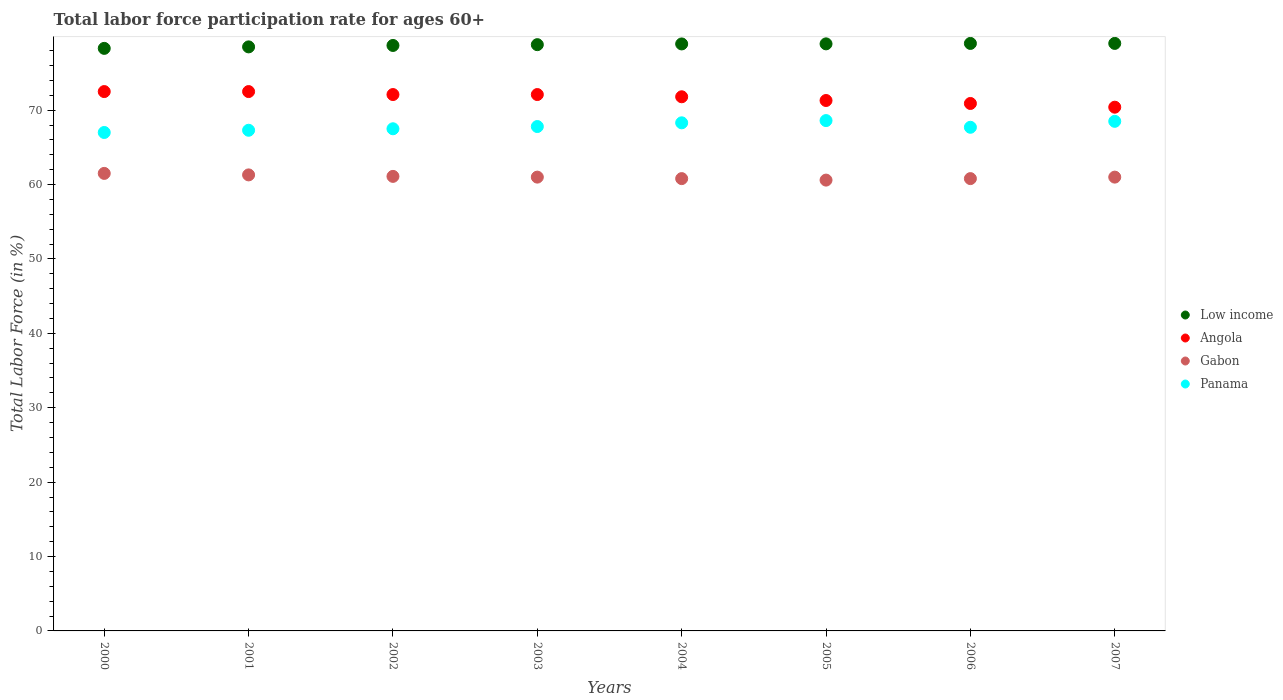What is the labor force participation rate in Angola in 2004?
Keep it short and to the point. 71.8. Across all years, what is the maximum labor force participation rate in Panama?
Offer a very short reply. 68.6. Across all years, what is the minimum labor force participation rate in Low income?
Your answer should be compact. 78.31. What is the total labor force participation rate in Angola in the graph?
Provide a short and direct response. 573.6. What is the difference between the labor force participation rate in Panama in 2001 and that in 2007?
Keep it short and to the point. -1.2. What is the difference between the labor force participation rate in Gabon in 2006 and the labor force participation rate in Low income in 2001?
Offer a terse response. -17.71. What is the average labor force participation rate in Angola per year?
Your answer should be very brief. 71.7. In the year 2002, what is the difference between the labor force participation rate in Angola and labor force participation rate in Panama?
Your answer should be compact. 4.6. In how many years, is the labor force participation rate in Angola greater than 40 %?
Make the answer very short. 8. What is the ratio of the labor force participation rate in Gabon in 2000 to that in 2001?
Your response must be concise. 1. Is the labor force participation rate in Gabon in 2000 less than that in 2002?
Offer a terse response. No. What is the difference between the highest and the second highest labor force participation rate in Panama?
Your answer should be compact. 0.1. What is the difference between the highest and the lowest labor force participation rate in Gabon?
Your answer should be very brief. 0.9. In how many years, is the labor force participation rate in Panama greater than the average labor force participation rate in Panama taken over all years?
Your response must be concise. 3. Is the labor force participation rate in Panama strictly greater than the labor force participation rate in Low income over the years?
Provide a succinct answer. No. Is the labor force participation rate in Angola strictly less than the labor force participation rate in Panama over the years?
Your answer should be compact. No. How many dotlines are there?
Your answer should be compact. 4. How many years are there in the graph?
Your answer should be very brief. 8. What is the difference between two consecutive major ticks on the Y-axis?
Give a very brief answer. 10. Does the graph contain any zero values?
Keep it short and to the point. No. Does the graph contain grids?
Provide a short and direct response. No. How many legend labels are there?
Make the answer very short. 4. How are the legend labels stacked?
Your answer should be very brief. Vertical. What is the title of the graph?
Provide a succinct answer. Total labor force participation rate for ages 60+. What is the label or title of the X-axis?
Keep it short and to the point. Years. What is the label or title of the Y-axis?
Your answer should be very brief. Total Labor Force (in %). What is the Total Labor Force (in %) of Low income in 2000?
Your answer should be compact. 78.31. What is the Total Labor Force (in %) of Angola in 2000?
Make the answer very short. 72.5. What is the Total Labor Force (in %) in Gabon in 2000?
Provide a short and direct response. 61.5. What is the Total Labor Force (in %) in Panama in 2000?
Offer a very short reply. 67. What is the Total Labor Force (in %) of Low income in 2001?
Your response must be concise. 78.51. What is the Total Labor Force (in %) in Angola in 2001?
Provide a succinct answer. 72.5. What is the Total Labor Force (in %) in Gabon in 2001?
Give a very brief answer. 61.3. What is the Total Labor Force (in %) in Panama in 2001?
Provide a short and direct response. 67.3. What is the Total Labor Force (in %) in Low income in 2002?
Provide a succinct answer. 78.7. What is the Total Labor Force (in %) of Angola in 2002?
Your response must be concise. 72.1. What is the Total Labor Force (in %) in Gabon in 2002?
Keep it short and to the point. 61.1. What is the Total Labor Force (in %) of Panama in 2002?
Your answer should be very brief. 67.5. What is the Total Labor Force (in %) of Low income in 2003?
Provide a short and direct response. 78.81. What is the Total Labor Force (in %) in Angola in 2003?
Make the answer very short. 72.1. What is the Total Labor Force (in %) of Panama in 2003?
Give a very brief answer. 67.8. What is the Total Labor Force (in %) of Low income in 2004?
Your answer should be compact. 78.9. What is the Total Labor Force (in %) of Angola in 2004?
Ensure brevity in your answer.  71.8. What is the Total Labor Force (in %) of Gabon in 2004?
Provide a succinct answer. 60.8. What is the Total Labor Force (in %) in Panama in 2004?
Keep it short and to the point. 68.3. What is the Total Labor Force (in %) in Low income in 2005?
Your response must be concise. 78.91. What is the Total Labor Force (in %) of Angola in 2005?
Your response must be concise. 71.3. What is the Total Labor Force (in %) of Gabon in 2005?
Your response must be concise. 60.6. What is the Total Labor Force (in %) in Panama in 2005?
Your answer should be very brief. 68.6. What is the Total Labor Force (in %) in Low income in 2006?
Make the answer very short. 78.97. What is the Total Labor Force (in %) of Angola in 2006?
Ensure brevity in your answer.  70.9. What is the Total Labor Force (in %) in Gabon in 2006?
Your response must be concise. 60.8. What is the Total Labor Force (in %) in Panama in 2006?
Your response must be concise. 67.7. What is the Total Labor Force (in %) in Low income in 2007?
Make the answer very short. 78.97. What is the Total Labor Force (in %) of Angola in 2007?
Keep it short and to the point. 70.4. What is the Total Labor Force (in %) of Panama in 2007?
Make the answer very short. 68.5. Across all years, what is the maximum Total Labor Force (in %) in Low income?
Your answer should be very brief. 78.97. Across all years, what is the maximum Total Labor Force (in %) of Angola?
Give a very brief answer. 72.5. Across all years, what is the maximum Total Labor Force (in %) in Gabon?
Offer a terse response. 61.5. Across all years, what is the maximum Total Labor Force (in %) of Panama?
Offer a very short reply. 68.6. Across all years, what is the minimum Total Labor Force (in %) in Low income?
Provide a short and direct response. 78.31. Across all years, what is the minimum Total Labor Force (in %) of Angola?
Your answer should be very brief. 70.4. Across all years, what is the minimum Total Labor Force (in %) of Gabon?
Ensure brevity in your answer.  60.6. Across all years, what is the minimum Total Labor Force (in %) of Panama?
Your answer should be very brief. 67. What is the total Total Labor Force (in %) of Low income in the graph?
Ensure brevity in your answer.  630.08. What is the total Total Labor Force (in %) in Angola in the graph?
Your response must be concise. 573.6. What is the total Total Labor Force (in %) in Gabon in the graph?
Offer a very short reply. 488.1. What is the total Total Labor Force (in %) in Panama in the graph?
Ensure brevity in your answer.  542.7. What is the difference between the Total Labor Force (in %) in Low income in 2000 and that in 2001?
Your response must be concise. -0.2. What is the difference between the Total Labor Force (in %) in Angola in 2000 and that in 2001?
Give a very brief answer. 0. What is the difference between the Total Labor Force (in %) of Low income in 2000 and that in 2002?
Give a very brief answer. -0.39. What is the difference between the Total Labor Force (in %) of Angola in 2000 and that in 2002?
Keep it short and to the point. 0.4. What is the difference between the Total Labor Force (in %) in Gabon in 2000 and that in 2002?
Ensure brevity in your answer.  0.4. What is the difference between the Total Labor Force (in %) of Panama in 2000 and that in 2002?
Offer a terse response. -0.5. What is the difference between the Total Labor Force (in %) in Low income in 2000 and that in 2003?
Offer a terse response. -0.5. What is the difference between the Total Labor Force (in %) in Panama in 2000 and that in 2003?
Your response must be concise. -0.8. What is the difference between the Total Labor Force (in %) of Low income in 2000 and that in 2004?
Give a very brief answer. -0.6. What is the difference between the Total Labor Force (in %) of Gabon in 2000 and that in 2004?
Keep it short and to the point. 0.7. What is the difference between the Total Labor Force (in %) of Low income in 2000 and that in 2005?
Keep it short and to the point. -0.61. What is the difference between the Total Labor Force (in %) of Gabon in 2000 and that in 2005?
Offer a terse response. 0.9. What is the difference between the Total Labor Force (in %) of Low income in 2000 and that in 2006?
Give a very brief answer. -0.66. What is the difference between the Total Labor Force (in %) in Gabon in 2000 and that in 2006?
Your response must be concise. 0.7. What is the difference between the Total Labor Force (in %) of Panama in 2000 and that in 2006?
Provide a succinct answer. -0.7. What is the difference between the Total Labor Force (in %) in Low income in 2000 and that in 2007?
Ensure brevity in your answer.  -0.67. What is the difference between the Total Labor Force (in %) of Angola in 2000 and that in 2007?
Offer a terse response. 2.1. What is the difference between the Total Labor Force (in %) of Gabon in 2000 and that in 2007?
Your response must be concise. 0.5. What is the difference between the Total Labor Force (in %) of Low income in 2001 and that in 2002?
Offer a terse response. -0.19. What is the difference between the Total Labor Force (in %) in Gabon in 2001 and that in 2002?
Ensure brevity in your answer.  0.2. What is the difference between the Total Labor Force (in %) of Panama in 2001 and that in 2002?
Give a very brief answer. -0.2. What is the difference between the Total Labor Force (in %) of Low income in 2001 and that in 2003?
Your answer should be very brief. -0.3. What is the difference between the Total Labor Force (in %) in Angola in 2001 and that in 2003?
Offer a very short reply. 0.4. What is the difference between the Total Labor Force (in %) of Low income in 2001 and that in 2004?
Provide a short and direct response. -0.4. What is the difference between the Total Labor Force (in %) in Angola in 2001 and that in 2004?
Ensure brevity in your answer.  0.7. What is the difference between the Total Labor Force (in %) of Low income in 2001 and that in 2005?
Make the answer very short. -0.41. What is the difference between the Total Labor Force (in %) of Angola in 2001 and that in 2005?
Your response must be concise. 1.2. What is the difference between the Total Labor Force (in %) in Gabon in 2001 and that in 2005?
Make the answer very short. 0.7. What is the difference between the Total Labor Force (in %) in Panama in 2001 and that in 2005?
Offer a very short reply. -1.3. What is the difference between the Total Labor Force (in %) of Low income in 2001 and that in 2006?
Provide a succinct answer. -0.46. What is the difference between the Total Labor Force (in %) in Angola in 2001 and that in 2006?
Ensure brevity in your answer.  1.6. What is the difference between the Total Labor Force (in %) of Gabon in 2001 and that in 2006?
Offer a very short reply. 0.5. What is the difference between the Total Labor Force (in %) in Panama in 2001 and that in 2006?
Ensure brevity in your answer.  -0.4. What is the difference between the Total Labor Force (in %) of Low income in 2001 and that in 2007?
Ensure brevity in your answer.  -0.47. What is the difference between the Total Labor Force (in %) in Gabon in 2001 and that in 2007?
Your response must be concise. 0.3. What is the difference between the Total Labor Force (in %) of Low income in 2002 and that in 2003?
Ensure brevity in your answer.  -0.11. What is the difference between the Total Labor Force (in %) of Gabon in 2002 and that in 2003?
Make the answer very short. 0.1. What is the difference between the Total Labor Force (in %) of Panama in 2002 and that in 2003?
Keep it short and to the point. -0.3. What is the difference between the Total Labor Force (in %) of Low income in 2002 and that in 2004?
Keep it short and to the point. -0.2. What is the difference between the Total Labor Force (in %) of Low income in 2002 and that in 2005?
Make the answer very short. -0.21. What is the difference between the Total Labor Force (in %) in Low income in 2002 and that in 2006?
Your response must be concise. -0.27. What is the difference between the Total Labor Force (in %) of Angola in 2002 and that in 2006?
Ensure brevity in your answer.  1.2. What is the difference between the Total Labor Force (in %) in Low income in 2002 and that in 2007?
Your answer should be compact. -0.28. What is the difference between the Total Labor Force (in %) in Gabon in 2002 and that in 2007?
Your answer should be very brief. 0.1. What is the difference between the Total Labor Force (in %) of Panama in 2002 and that in 2007?
Your response must be concise. -1. What is the difference between the Total Labor Force (in %) in Low income in 2003 and that in 2004?
Your response must be concise. -0.1. What is the difference between the Total Labor Force (in %) of Gabon in 2003 and that in 2004?
Keep it short and to the point. 0.2. What is the difference between the Total Labor Force (in %) of Panama in 2003 and that in 2004?
Ensure brevity in your answer.  -0.5. What is the difference between the Total Labor Force (in %) of Low income in 2003 and that in 2005?
Your answer should be compact. -0.11. What is the difference between the Total Labor Force (in %) of Gabon in 2003 and that in 2005?
Provide a short and direct response. 0.4. What is the difference between the Total Labor Force (in %) in Low income in 2003 and that in 2006?
Your answer should be compact. -0.17. What is the difference between the Total Labor Force (in %) of Gabon in 2003 and that in 2006?
Make the answer very short. 0.2. What is the difference between the Total Labor Force (in %) in Low income in 2003 and that in 2007?
Provide a succinct answer. -0.17. What is the difference between the Total Labor Force (in %) in Angola in 2003 and that in 2007?
Your response must be concise. 1.7. What is the difference between the Total Labor Force (in %) of Low income in 2004 and that in 2005?
Keep it short and to the point. -0.01. What is the difference between the Total Labor Force (in %) in Angola in 2004 and that in 2005?
Keep it short and to the point. 0.5. What is the difference between the Total Labor Force (in %) in Low income in 2004 and that in 2006?
Offer a very short reply. -0.07. What is the difference between the Total Labor Force (in %) in Panama in 2004 and that in 2006?
Ensure brevity in your answer.  0.6. What is the difference between the Total Labor Force (in %) in Low income in 2004 and that in 2007?
Your answer should be very brief. -0.07. What is the difference between the Total Labor Force (in %) in Gabon in 2004 and that in 2007?
Keep it short and to the point. -0.2. What is the difference between the Total Labor Force (in %) in Panama in 2004 and that in 2007?
Your answer should be very brief. -0.2. What is the difference between the Total Labor Force (in %) in Low income in 2005 and that in 2006?
Your response must be concise. -0.06. What is the difference between the Total Labor Force (in %) of Angola in 2005 and that in 2006?
Your answer should be compact. 0.4. What is the difference between the Total Labor Force (in %) of Gabon in 2005 and that in 2006?
Offer a terse response. -0.2. What is the difference between the Total Labor Force (in %) in Low income in 2005 and that in 2007?
Make the answer very short. -0.06. What is the difference between the Total Labor Force (in %) of Angola in 2005 and that in 2007?
Offer a terse response. 0.9. What is the difference between the Total Labor Force (in %) of Low income in 2006 and that in 2007?
Ensure brevity in your answer.  -0. What is the difference between the Total Labor Force (in %) in Low income in 2000 and the Total Labor Force (in %) in Angola in 2001?
Provide a succinct answer. 5.81. What is the difference between the Total Labor Force (in %) of Low income in 2000 and the Total Labor Force (in %) of Gabon in 2001?
Ensure brevity in your answer.  17.01. What is the difference between the Total Labor Force (in %) in Low income in 2000 and the Total Labor Force (in %) in Panama in 2001?
Give a very brief answer. 11.01. What is the difference between the Total Labor Force (in %) in Gabon in 2000 and the Total Labor Force (in %) in Panama in 2001?
Ensure brevity in your answer.  -5.8. What is the difference between the Total Labor Force (in %) of Low income in 2000 and the Total Labor Force (in %) of Angola in 2002?
Your answer should be very brief. 6.21. What is the difference between the Total Labor Force (in %) in Low income in 2000 and the Total Labor Force (in %) in Gabon in 2002?
Ensure brevity in your answer.  17.21. What is the difference between the Total Labor Force (in %) in Low income in 2000 and the Total Labor Force (in %) in Panama in 2002?
Ensure brevity in your answer.  10.81. What is the difference between the Total Labor Force (in %) in Angola in 2000 and the Total Labor Force (in %) in Panama in 2002?
Keep it short and to the point. 5. What is the difference between the Total Labor Force (in %) of Gabon in 2000 and the Total Labor Force (in %) of Panama in 2002?
Your answer should be compact. -6. What is the difference between the Total Labor Force (in %) of Low income in 2000 and the Total Labor Force (in %) of Angola in 2003?
Your answer should be compact. 6.21. What is the difference between the Total Labor Force (in %) in Low income in 2000 and the Total Labor Force (in %) in Gabon in 2003?
Your answer should be very brief. 17.31. What is the difference between the Total Labor Force (in %) of Low income in 2000 and the Total Labor Force (in %) of Panama in 2003?
Your answer should be very brief. 10.51. What is the difference between the Total Labor Force (in %) in Angola in 2000 and the Total Labor Force (in %) in Panama in 2003?
Provide a succinct answer. 4.7. What is the difference between the Total Labor Force (in %) of Low income in 2000 and the Total Labor Force (in %) of Angola in 2004?
Your response must be concise. 6.51. What is the difference between the Total Labor Force (in %) in Low income in 2000 and the Total Labor Force (in %) in Gabon in 2004?
Offer a terse response. 17.51. What is the difference between the Total Labor Force (in %) in Low income in 2000 and the Total Labor Force (in %) in Panama in 2004?
Offer a very short reply. 10.01. What is the difference between the Total Labor Force (in %) of Angola in 2000 and the Total Labor Force (in %) of Gabon in 2004?
Your answer should be very brief. 11.7. What is the difference between the Total Labor Force (in %) of Angola in 2000 and the Total Labor Force (in %) of Panama in 2004?
Your response must be concise. 4.2. What is the difference between the Total Labor Force (in %) in Low income in 2000 and the Total Labor Force (in %) in Angola in 2005?
Give a very brief answer. 7.01. What is the difference between the Total Labor Force (in %) in Low income in 2000 and the Total Labor Force (in %) in Gabon in 2005?
Make the answer very short. 17.71. What is the difference between the Total Labor Force (in %) in Low income in 2000 and the Total Labor Force (in %) in Panama in 2005?
Your answer should be very brief. 9.71. What is the difference between the Total Labor Force (in %) of Angola in 2000 and the Total Labor Force (in %) of Gabon in 2005?
Keep it short and to the point. 11.9. What is the difference between the Total Labor Force (in %) in Angola in 2000 and the Total Labor Force (in %) in Panama in 2005?
Your answer should be very brief. 3.9. What is the difference between the Total Labor Force (in %) in Gabon in 2000 and the Total Labor Force (in %) in Panama in 2005?
Your answer should be very brief. -7.1. What is the difference between the Total Labor Force (in %) of Low income in 2000 and the Total Labor Force (in %) of Angola in 2006?
Keep it short and to the point. 7.41. What is the difference between the Total Labor Force (in %) of Low income in 2000 and the Total Labor Force (in %) of Gabon in 2006?
Your answer should be very brief. 17.51. What is the difference between the Total Labor Force (in %) in Low income in 2000 and the Total Labor Force (in %) in Panama in 2006?
Your answer should be very brief. 10.61. What is the difference between the Total Labor Force (in %) of Low income in 2000 and the Total Labor Force (in %) of Angola in 2007?
Provide a succinct answer. 7.91. What is the difference between the Total Labor Force (in %) in Low income in 2000 and the Total Labor Force (in %) in Gabon in 2007?
Make the answer very short. 17.31. What is the difference between the Total Labor Force (in %) of Low income in 2000 and the Total Labor Force (in %) of Panama in 2007?
Ensure brevity in your answer.  9.81. What is the difference between the Total Labor Force (in %) in Angola in 2000 and the Total Labor Force (in %) in Gabon in 2007?
Offer a terse response. 11.5. What is the difference between the Total Labor Force (in %) of Angola in 2000 and the Total Labor Force (in %) of Panama in 2007?
Offer a very short reply. 4. What is the difference between the Total Labor Force (in %) of Gabon in 2000 and the Total Labor Force (in %) of Panama in 2007?
Keep it short and to the point. -7. What is the difference between the Total Labor Force (in %) in Low income in 2001 and the Total Labor Force (in %) in Angola in 2002?
Provide a short and direct response. 6.41. What is the difference between the Total Labor Force (in %) in Low income in 2001 and the Total Labor Force (in %) in Gabon in 2002?
Provide a succinct answer. 17.41. What is the difference between the Total Labor Force (in %) in Low income in 2001 and the Total Labor Force (in %) in Panama in 2002?
Offer a very short reply. 11.01. What is the difference between the Total Labor Force (in %) of Angola in 2001 and the Total Labor Force (in %) of Panama in 2002?
Your answer should be compact. 5. What is the difference between the Total Labor Force (in %) of Low income in 2001 and the Total Labor Force (in %) of Angola in 2003?
Your answer should be very brief. 6.41. What is the difference between the Total Labor Force (in %) in Low income in 2001 and the Total Labor Force (in %) in Gabon in 2003?
Offer a terse response. 17.51. What is the difference between the Total Labor Force (in %) of Low income in 2001 and the Total Labor Force (in %) of Panama in 2003?
Give a very brief answer. 10.71. What is the difference between the Total Labor Force (in %) in Gabon in 2001 and the Total Labor Force (in %) in Panama in 2003?
Provide a short and direct response. -6.5. What is the difference between the Total Labor Force (in %) in Low income in 2001 and the Total Labor Force (in %) in Angola in 2004?
Your answer should be compact. 6.71. What is the difference between the Total Labor Force (in %) of Low income in 2001 and the Total Labor Force (in %) of Gabon in 2004?
Provide a short and direct response. 17.71. What is the difference between the Total Labor Force (in %) of Low income in 2001 and the Total Labor Force (in %) of Panama in 2004?
Make the answer very short. 10.21. What is the difference between the Total Labor Force (in %) of Angola in 2001 and the Total Labor Force (in %) of Gabon in 2004?
Ensure brevity in your answer.  11.7. What is the difference between the Total Labor Force (in %) in Gabon in 2001 and the Total Labor Force (in %) in Panama in 2004?
Your answer should be very brief. -7. What is the difference between the Total Labor Force (in %) of Low income in 2001 and the Total Labor Force (in %) of Angola in 2005?
Offer a very short reply. 7.21. What is the difference between the Total Labor Force (in %) in Low income in 2001 and the Total Labor Force (in %) in Gabon in 2005?
Your answer should be very brief. 17.91. What is the difference between the Total Labor Force (in %) in Low income in 2001 and the Total Labor Force (in %) in Panama in 2005?
Your answer should be compact. 9.91. What is the difference between the Total Labor Force (in %) in Angola in 2001 and the Total Labor Force (in %) in Gabon in 2005?
Provide a short and direct response. 11.9. What is the difference between the Total Labor Force (in %) of Angola in 2001 and the Total Labor Force (in %) of Panama in 2005?
Make the answer very short. 3.9. What is the difference between the Total Labor Force (in %) of Gabon in 2001 and the Total Labor Force (in %) of Panama in 2005?
Keep it short and to the point. -7.3. What is the difference between the Total Labor Force (in %) of Low income in 2001 and the Total Labor Force (in %) of Angola in 2006?
Keep it short and to the point. 7.61. What is the difference between the Total Labor Force (in %) of Low income in 2001 and the Total Labor Force (in %) of Gabon in 2006?
Ensure brevity in your answer.  17.71. What is the difference between the Total Labor Force (in %) of Low income in 2001 and the Total Labor Force (in %) of Panama in 2006?
Your answer should be very brief. 10.81. What is the difference between the Total Labor Force (in %) of Low income in 2001 and the Total Labor Force (in %) of Angola in 2007?
Offer a very short reply. 8.11. What is the difference between the Total Labor Force (in %) of Low income in 2001 and the Total Labor Force (in %) of Gabon in 2007?
Provide a succinct answer. 17.51. What is the difference between the Total Labor Force (in %) in Low income in 2001 and the Total Labor Force (in %) in Panama in 2007?
Keep it short and to the point. 10.01. What is the difference between the Total Labor Force (in %) in Angola in 2001 and the Total Labor Force (in %) in Panama in 2007?
Make the answer very short. 4. What is the difference between the Total Labor Force (in %) of Gabon in 2001 and the Total Labor Force (in %) of Panama in 2007?
Your response must be concise. -7.2. What is the difference between the Total Labor Force (in %) in Low income in 2002 and the Total Labor Force (in %) in Angola in 2003?
Your answer should be very brief. 6.6. What is the difference between the Total Labor Force (in %) of Low income in 2002 and the Total Labor Force (in %) of Gabon in 2003?
Keep it short and to the point. 17.7. What is the difference between the Total Labor Force (in %) of Low income in 2002 and the Total Labor Force (in %) of Panama in 2003?
Ensure brevity in your answer.  10.9. What is the difference between the Total Labor Force (in %) of Angola in 2002 and the Total Labor Force (in %) of Panama in 2003?
Offer a very short reply. 4.3. What is the difference between the Total Labor Force (in %) of Gabon in 2002 and the Total Labor Force (in %) of Panama in 2003?
Your answer should be very brief. -6.7. What is the difference between the Total Labor Force (in %) of Low income in 2002 and the Total Labor Force (in %) of Angola in 2004?
Your answer should be compact. 6.9. What is the difference between the Total Labor Force (in %) in Low income in 2002 and the Total Labor Force (in %) in Gabon in 2004?
Provide a succinct answer. 17.9. What is the difference between the Total Labor Force (in %) in Low income in 2002 and the Total Labor Force (in %) in Panama in 2004?
Provide a short and direct response. 10.4. What is the difference between the Total Labor Force (in %) in Low income in 2002 and the Total Labor Force (in %) in Angola in 2005?
Offer a terse response. 7.4. What is the difference between the Total Labor Force (in %) of Low income in 2002 and the Total Labor Force (in %) of Gabon in 2005?
Keep it short and to the point. 18.1. What is the difference between the Total Labor Force (in %) of Low income in 2002 and the Total Labor Force (in %) of Panama in 2005?
Your answer should be compact. 10.1. What is the difference between the Total Labor Force (in %) in Angola in 2002 and the Total Labor Force (in %) in Panama in 2005?
Keep it short and to the point. 3.5. What is the difference between the Total Labor Force (in %) of Low income in 2002 and the Total Labor Force (in %) of Angola in 2006?
Your answer should be very brief. 7.8. What is the difference between the Total Labor Force (in %) in Low income in 2002 and the Total Labor Force (in %) in Gabon in 2006?
Offer a terse response. 17.9. What is the difference between the Total Labor Force (in %) in Low income in 2002 and the Total Labor Force (in %) in Panama in 2006?
Your answer should be compact. 11. What is the difference between the Total Labor Force (in %) in Angola in 2002 and the Total Labor Force (in %) in Gabon in 2006?
Provide a succinct answer. 11.3. What is the difference between the Total Labor Force (in %) in Low income in 2002 and the Total Labor Force (in %) in Angola in 2007?
Your response must be concise. 8.3. What is the difference between the Total Labor Force (in %) of Low income in 2002 and the Total Labor Force (in %) of Gabon in 2007?
Your answer should be very brief. 17.7. What is the difference between the Total Labor Force (in %) of Low income in 2002 and the Total Labor Force (in %) of Panama in 2007?
Keep it short and to the point. 10.2. What is the difference between the Total Labor Force (in %) of Angola in 2002 and the Total Labor Force (in %) of Panama in 2007?
Give a very brief answer. 3.6. What is the difference between the Total Labor Force (in %) in Gabon in 2002 and the Total Labor Force (in %) in Panama in 2007?
Offer a terse response. -7.4. What is the difference between the Total Labor Force (in %) in Low income in 2003 and the Total Labor Force (in %) in Angola in 2004?
Your answer should be very brief. 7.01. What is the difference between the Total Labor Force (in %) in Low income in 2003 and the Total Labor Force (in %) in Gabon in 2004?
Make the answer very short. 18.01. What is the difference between the Total Labor Force (in %) in Low income in 2003 and the Total Labor Force (in %) in Panama in 2004?
Provide a succinct answer. 10.51. What is the difference between the Total Labor Force (in %) of Low income in 2003 and the Total Labor Force (in %) of Angola in 2005?
Your response must be concise. 7.51. What is the difference between the Total Labor Force (in %) in Low income in 2003 and the Total Labor Force (in %) in Gabon in 2005?
Provide a succinct answer. 18.21. What is the difference between the Total Labor Force (in %) in Low income in 2003 and the Total Labor Force (in %) in Panama in 2005?
Offer a very short reply. 10.21. What is the difference between the Total Labor Force (in %) of Angola in 2003 and the Total Labor Force (in %) of Gabon in 2005?
Offer a terse response. 11.5. What is the difference between the Total Labor Force (in %) of Low income in 2003 and the Total Labor Force (in %) of Angola in 2006?
Make the answer very short. 7.91. What is the difference between the Total Labor Force (in %) in Low income in 2003 and the Total Labor Force (in %) in Gabon in 2006?
Your response must be concise. 18.01. What is the difference between the Total Labor Force (in %) of Low income in 2003 and the Total Labor Force (in %) of Panama in 2006?
Provide a short and direct response. 11.11. What is the difference between the Total Labor Force (in %) in Angola in 2003 and the Total Labor Force (in %) in Gabon in 2006?
Make the answer very short. 11.3. What is the difference between the Total Labor Force (in %) in Angola in 2003 and the Total Labor Force (in %) in Panama in 2006?
Make the answer very short. 4.4. What is the difference between the Total Labor Force (in %) of Gabon in 2003 and the Total Labor Force (in %) of Panama in 2006?
Offer a very short reply. -6.7. What is the difference between the Total Labor Force (in %) in Low income in 2003 and the Total Labor Force (in %) in Angola in 2007?
Your answer should be compact. 8.41. What is the difference between the Total Labor Force (in %) of Low income in 2003 and the Total Labor Force (in %) of Gabon in 2007?
Your response must be concise. 17.81. What is the difference between the Total Labor Force (in %) in Low income in 2003 and the Total Labor Force (in %) in Panama in 2007?
Offer a very short reply. 10.31. What is the difference between the Total Labor Force (in %) of Gabon in 2003 and the Total Labor Force (in %) of Panama in 2007?
Your answer should be very brief. -7.5. What is the difference between the Total Labor Force (in %) of Low income in 2004 and the Total Labor Force (in %) of Angola in 2005?
Give a very brief answer. 7.6. What is the difference between the Total Labor Force (in %) of Low income in 2004 and the Total Labor Force (in %) of Gabon in 2005?
Provide a succinct answer. 18.3. What is the difference between the Total Labor Force (in %) in Low income in 2004 and the Total Labor Force (in %) in Panama in 2005?
Give a very brief answer. 10.3. What is the difference between the Total Labor Force (in %) in Angola in 2004 and the Total Labor Force (in %) in Gabon in 2005?
Give a very brief answer. 11.2. What is the difference between the Total Labor Force (in %) in Angola in 2004 and the Total Labor Force (in %) in Panama in 2005?
Provide a succinct answer. 3.2. What is the difference between the Total Labor Force (in %) of Low income in 2004 and the Total Labor Force (in %) of Angola in 2006?
Ensure brevity in your answer.  8. What is the difference between the Total Labor Force (in %) of Low income in 2004 and the Total Labor Force (in %) of Gabon in 2006?
Offer a very short reply. 18.1. What is the difference between the Total Labor Force (in %) in Low income in 2004 and the Total Labor Force (in %) in Panama in 2006?
Keep it short and to the point. 11.2. What is the difference between the Total Labor Force (in %) in Angola in 2004 and the Total Labor Force (in %) in Gabon in 2006?
Give a very brief answer. 11. What is the difference between the Total Labor Force (in %) of Gabon in 2004 and the Total Labor Force (in %) of Panama in 2006?
Ensure brevity in your answer.  -6.9. What is the difference between the Total Labor Force (in %) of Low income in 2004 and the Total Labor Force (in %) of Angola in 2007?
Make the answer very short. 8.5. What is the difference between the Total Labor Force (in %) of Low income in 2004 and the Total Labor Force (in %) of Gabon in 2007?
Provide a short and direct response. 17.9. What is the difference between the Total Labor Force (in %) in Low income in 2004 and the Total Labor Force (in %) in Panama in 2007?
Your answer should be very brief. 10.4. What is the difference between the Total Labor Force (in %) of Angola in 2004 and the Total Labor Force (in %) of Gabon in 2007?
Give a very brief answer. 10.8. What is the difference between the Total Labor Force (in %) in Low income in 2005 and the Total Labor Force (in %) in Angola in 2006?
Your response must be concise. 8.01. What is the difference between the Total Labor Force (in %) in Low income in 2005 and the Total Labor Force (in %) in Gabon in 2006?
Provide a succinct answer. 18.11. What is the difference between the Total Labor Force (in %) in Low income in 2005 and the Total Labor Force (in %) in Panama in 2006?
Your answer should be compact. 11.21. What is the difference between the Total Labor Force (in %) in Angola in 2005 and the Total Labor Force (in %) in Panama in 2006?
Keep it short and to the point. 3.6. What is the difference between the Total Labor Force (in %) of Low income in 2005 and the Total Labor Force (in %) of Angola in 2007?
Keep it short and to the point. 8.51. What is the difference between the Total Labor Force (in %) in Low income in 2005 and the Total Labor Force (in %) in Gabon in 2007?
Your answer should be very brief. 17.91. What is the difference between the Total Labor Force (in %) in Low income in 2005 and the Total Labor Force (in %) in Panama in 2007?
Provide a short and direct response. 10.41. What is the difference between the Total Labor Force (in %) in Gabon in 2005 and the Total Labor Force (in %) in Panama in 2007?
Provide a short and direct response. -7.9. What is the difference between the Total Labor Force (in %) in Low income in 2006 and the Total Labor Force (in %) in Angola in 2007?
Make the answer very short. 8.57. What is the difference between the Total Labor Force (in %) of Low income in 2006 and the Total Labor Force (in %) of Gabon in 2007?
Keep it short and to the point. 17.97. What is the difference between the Total Labor Force (in %) in Low income in 2006 and the Total Labor Force (in %) in Panama in 2007?
Make the answer very short. 10.47. What is the average Total Labor Force (in %) in Low income per year?
Your answer should be compact. 78.76. What is the average Total Labor Force (in %) of Angola per year?
Offer a very short reply. 71.7. What is the average Total Labor Force (in %) of Gabon per year?
Your answer should be compact. 61.01. What is the average Total Labor Force (in %) in Panama per year?
Provide a succinct answer. 67.84. In the year 2000, what is the difference between the Total Labor Force (in %) of Low income and Total Labor Force (in %) of Angola?
Ensure brevity in your answer.  5.81. In the year 2000, what is the difference between the Total Labor Force (in %) in Low income and Total Labor Force (in %) in Gabon?
Offer a terse response. 16.81. In the year 2000, what is the difference between the Total Labor Force (in %) in Low income and Total Labor Force (in %) in Panama?
Ensure brevity in your answer.  11.31. In the year 2000, what is the difference between the Total Labor Force (in %) in Gabon and Total Labor Force (in %) in Panama?
Keep it short and to the point. -5.5. In the year 2001, what is the difference between the Total Labor Force (in %) in Low income and Total Labor Force (in %) in Angola?
Your response must be concise. 6.01. In the year 2001, what is the difference between the Total Labor Force (in %) of Low income and Total Labor Force (in %) of Gabon?
Keep it short and to the point. 17.21. In the year 2001, what is the difference between the Total Labor Force (in %) in Low income and Total Labor Force (in %) in Panama?
Your response must be concise. 11.21. In the year 2001, what is the difference between the Total Labor Force (in %) in Angola and Total Labor Force (in %) in Gabon?
Ensure brevity in your answer.  11.2. In the year 2001, what is the difference between the Total Labor Force (in %) in Gabon and Total Labor Force (in %) in Panama?
Offer a terse response. -6. In the year 2002, what is the difference between the Total Labor Force (in %) of Low income and Total Labor Force (in %) of Angola?
Give a very brief answer. 6.6. In the year 2002, what is the difference between the Total Labor Force (in %) in Low income and Total Labor Force (in %) in Gabon?
Offer a terse response. 17.6. In the year 2002, what is the difference between the Total Labor Force (in %) of Low income and Total Labor Force (in %) of Panama?
Make the answer very short. 11.2. In the year 2002, what is the difference between the Total Labor Force (in %) of Angola and Total Labor Force (in %) of Gabon?
Ensure brevity in your answer.  11. In the year 2002, what is the difference between the Total Labor Force (in %) in Angola and Total Labor Force (in %) in Panama?
Make the answer very short. 4.6. In the year 2002, what is the difference between the Total Labor Force (in %) in Gabon and Total Labor Force (in %) in Panama?
Your answer should be very brief. -6.4. In the year 2003, what is the difference between the Total Labor Force (in %) in Low income and Total Labor Force (in %) in Angola?
Offer a very short reply. 6.71. In the year 2003, what is the difference between the Total Labor Force (in %) in Low income and Total Labor Force (in %) in Gabon?
Ensure brevity in your answer.  17.81. In the year 2003, what is the difference between the Total Labor Force (in %) in Low income and Total Labor Force (in %) in Panama?
Offer a terse response. 11.01. In the year 2003, what is the difference between the Total Labor Force (in %) in Gabon and Total Labor Force (in %) in Panama?
Your answer should be very brief. -6.8. In the year 2004, what is the difference between the Total Labor Force (in %) in Low income and Total Labor Force (in %) in Angola?
Give a very brief answer. 7.1. In the year 2004, what is the difference between the Total Labor Force (in %) of Low income and Total Labor Force (in %) of Gabon?
Give a very brief answer. 18.1. In the year 2004, what is the difference between the Total Labor Force (in %) of Low income and Total Labor Force (in %) of Panama?
Offer a terse response. 10.6. In the year 2004, what is the difference between the Total Labor Force (in %) in Angola and Total Labor Force (in %) in Gabon?
Make the answer very short. 11. In the year 2004, what is the difference between the Total Labor Force (in %) of Angola and Total Labor Force (in %) of Panama?
Provide a short and direct response. 3.5. In the year 2004, what is the difference between the Total Labor Force (in %) of Gabon and Total Labor Force (in %) of Panama?
Your answer should be compact. -7.5. In the year 2005, what is the difference between the Total Labor Force (in %) in Low income and Total Labor Force (in %) in Angola?
Your answer should be very brief. 7.61. In the year 2005, what is the difference between the Total Labor Force (in %) of Low income and Total Labor Force (in %) of Gabon?
Offer a terse response. 18.31. In the year 2005, what is the difference between the Total Labor Force (in %) of Low income and Total Labor Force (in %) of Panama?
Offer a terse response. 10.31. In the year 2006, what is the difference between the Total Labor Force (in %) in Low income and Total Labor Force (in %) in Angola?
Make the answer very short. 8.07. In the year 2006, what is the difference between the Total Labor Force (in %) of Low income and Total Labor Force (in %) of Gabon?
Offer a very short reply. 18.17. In the year 2006, what is the difference between the Total Labor Force (in %) in Low income and Total Labor Force (in %) in Panama?
Your answer should be very brief. 11.27. In the year 2006, what is the difference between the Total Labor Force (in %) in Angola and Total Labor Force (in %) in Gabon?
Make the answer very short. 10.1. In the year 2006, what is the difference between the Total Labor Force (in %) in Angola and Total Labor Force (in %) in Panama?
Your answer should be very brief. 3.2. In the year 2007, what is the difference between the Total Labor Force (in %) in Low income and Total Labor Force (in %) in Angola?
Provide a short and direct response. 8.57. In the year 2007, what is the difference between the Total Labor Force (in %) of Low income and Total Labor Force (in %) of Gabon?
Make the answer very short. 17.97. In the year 2007, what is the difference between the Total Labor Force (in %) of Low income and Total Labor Force (in %) of Panama?
Ensure brevity in your answer.  10.47. In the year 2007, what is the difference between the Total Labor Force (in %) in Angola and Total Labor Force (in %) in Gabon?
Provide a succinct answer. 9.4. In the year 2007, what is the difference between the Total Labor Force (in %) in Angola and Total Labor Force (in %) in Panama?
Keep it short and to the point. 1.9. What is the ratio of the Total Labor Force (in %) of Low income in 2000 to that in 2001?
Provide a succinct answer. 1. What is the ratio of the Total Labor Force (in %) of Gabon in 2000 to that in 2001?
Make the answer very short. 1. What is the ratio of the Total Labor Force (in %) in Gabon in 2000 to that in 2002?
Your response must be concise. 1.01. What is the ratio of the Total Labor Force (in %) of Low income in 2000 to that in 2003?
Make the answer very short. 0.99. What is the ratio of the Total Labor Force (in %) of Angola in 2000 to that in 2003?
Make the answer very short. 1.01. What is the ratio of the Total Labor Force (in %) in Gabon in 2000 to that in 2003?
Provide a succinct answer. 1.01. What is the ratio of the Total Labor Force (in %) of Panama in 2000 to that in 2003?
Give a very brief answer. 0.99. What is the ratio of the Total Labor Force (in %) in Angola in 2000 to that in 2004?
Provide a short and direct response. 1.01. What is the ratio of the Total Labor Force (in %) in Gabon in 2000 to that in 2004?
Offer a terse response. 1.01. What is the ratio of the Total Labor Force (in %) of Low income in 2000 to that in 2005?
Your answer should be very brief. 0.99. What is the ratio of the Total Labor Force (in %) of Angola in 2000 to that in 2005?
Provide a short and direct response. 1.02. What is the ratio of the Total Labor Force (in %) in Gabon in 2000 to that in 2005?
Your answer should be compact. 1.01. What is the ratio of the Total Labor Force (in %) of Panama in 2000 to that in 2005?
Offer a terse response. 0.98. What is the ratio of the Total Labor Force (in %) of Angola in 2000 to that in 2006?
Your response must be concise. 1.02. What is the ratio of the Total Labor Force (in %) in Gabon in 2000 to that in 2006?
Offer a terse response. 1.01. What is the ratio of the Total Labor Force (in %) in Panama in 2000 to that in 2006?
Provide a short and direct response. 0.99. What is the ratio of the Total Labor Force (in %) in Angola in 2000 to that in 2007?
Keep it short and to the point. 1.03. What is the ratio of the Total Labor Force (in %) in Gabon in 2000 to that in 2007?
Ensure brevity in your answer.  1.01. What is the ratio of the Total Labor Force (in %) in Panama in 2000 to that in 2007?
Offer a very short reply. 0.98. What is the ratio of the Total Labor Force (in %) in Gabon in 2001 to that in 2002?
Keep it short and to the point. 1. What is the ratio of the Total Labor Force (in %) of Panama in 2001 to that in 2002?
Your answer should be compact. 1. What is the ratio of the Total Labor Force (in %) in Low income in 2001 to that in 2003?
Provide a short and direct response. 1. What is the ratio of the Total Labor Force (in %) of Panama in 2001 to that in 2003?
Keep it short and to the point. 0.99. What is the ratio of the Total Labor Force (in %) in Low income in 2001 to that in 2004?
Your answer should be very brief. 0.99. What is the ratio of the Total Labor Force (in %) in Angola in 2001 to that in 2004?
Keep it short and to the point. 1.01. What is the ratio of the Total Labor Force (in %) in Gabon in 2001 to that in 2004?
Provide a short and direct response. 1.01. What is the ratio of the Total Labor Force (in %) of Panama in 2001 to that in 2004?
Provide a short and direct response. 0.99. What is the ratio of the Total Labor Force (in %) of Low income in 2001 to that in 2005?
Keep it short and to the point. 0.99. What is the ratio of the Total Labor Force (in %) in Angola in 2001 to that in 2005?
Offer a terse response. 1.02. What is the ratio of the Total Labor Force (in %) in Gabon in 2001 to that in 2005?
Ensure brevity in your answer.  1.01. What is the ratio of the Total Labor Force (in %) of Low income in 2001 to that in 2006?
Provide a short and direct response. 0.99. What is the ratio of the Total Labor Force (in %) of Angola in 2001 to that in 2006?
Provide a succinct answer. 1.02. What is the ratio of the Total Labor Force (in %) of Gabon in 2001 to that in 2006?
Make the answer very short. 1.01. What is the ratio of the Total Labor Force (in %) in Angola in 2001 to that in 2007?
Your response must be concise. 1.03. What is the ratio of the Total Labor Force (in %) of Gabon in 2001 to that in 2007?
Offer a very short reply. 1. What is the ratio of the Total Labor Force (in %) of Panama in 2001 to that in 2007?
Your answer should be compact. 0.98. What is the ratio of the Total Labor Force (in %) of Angola in 2002 to that in 2003?
Your answer should be compact. 1. What is the ratio of the Total Labor Force (in %) of Gabon in 2002 to that in 2003?
Provide a succinct answer. 1. What is the ratio of the Total Labor Force (in %) in Panama in 2002 to that in 2003?
Make the answer very short. 1. What is the ratio of the Total Labor Force (in %) in Low income in 2002 to that in 2004?
Provide a short and direct response. 1. What is the ratio of the Total Labor Force (in %) in Angola in 2002 to that in 2004?
Keep it short and to the point. 1. What is the ratio of the Total Labor Force (in %) of Gabon in 2002 to that in 2004?
Provide a short and direct response. 1. What is the ratio of the Total Labor Force (in %) of Panama in 2002 to that in 2004?
Offer a very short reply. 0.99. What is the ratio of the Total Labor Force (in %) in Low income in 2002 to that in 2005?
Keep it short and to the point. 1. What is the ratio of the Total Labor Force (in %) of Angola in 2002 to that in 2005?
Offer a terse response. 1.01. What is the ratio of the Total Labor Force (in %) in Gabon in 2002 to that in 2005?
Your response must be concise. 1.01. What is the ratio of the Total Labor Force (in %) of Low income in 2002 to that in 2006?
Provide a succinct answer. 1. What is the ratio of the Total Labor Force (in %) in Angola in 2002 to that in 2006?
Ensure brevity in your answer.  1.02. What is the ratio of the Total Labor Force (in %) in Gabon in 2002 to that in 2006?
Provide a short and direct response. 1. What is the ratio of the Total Labor Force (in %) in Panama in 2002 to that in 2006?
Offer a very short reply. 1. What is the ratio of the Total Labor Force (in %) in Low income in 2002 to that in 2007?
Your answer should be compact. 1. What is the ratio of the Total Labor Force (in %) of Angola in 2002 to that in 2007?
Your answer should be compact. 1.02. What is the ratio of the Total Labor Force (in %) of Gabon in 2002 to that in 2007?
Your answer should be compact. 1. What is the ratio of the Total Labor Force (in %) of Panama in 2002 to that in 2007?
Offer a very short reply. 0.99. What is the ratio of the Total Labor Force (in %) of Angola in 2003 to that in 2005?
Offer a very short reply. 1.01. What is the ratio of the Total Labor Force (in %) of Gabon in 2003 to that in 2005?
Keep it short and to the point. 1.01. What is the ratio of the Total Labor Force (in %) of Panama in 2003 to that in 2005?
Keep it short and to the point. 0.99. What is the ratio of the Total Labor Force (in %) in Low income in 2003 to that in 2006?
Give a very brief answer. 1. What is the ratio of the Total Labor Force (in %) of Angola in 2003 to that in 2006?
Your response must be concise. 1.02. What is the ratio of the Total Labor Force (in %) in Panama in 2003 to that in 2006?
Your answer should be very brief. 1. What is the ratio of the Total Labor Force (in %) of Low income in 2003 to that in 2007?
Provide a short and direct response. 1. What is the ratio of the Total Labor Force (in %) of Angola in 2003 to that in 2007?
Offer a terse response. 1.02. What is the ratio of the Total Labor Force (in %) of Gabon in 2003 to that in 2007?
Your response must be concise. 1. What is the ratio of the Total Labor Force (in %) of Panama in 2003 to that in 2007?
Your response must be concise. 0.99. What is the ratio of the Total Labor Force (in %) in Angola in 2004 to that in 2005?
Offer a terse response. 1.01. What is the ratio of the Total Labor Force (in %) of Low income in 2004 to that in 2006?
Your answer should be very brief. 1. What is the ratio of the Total Labor Force (in %) of Angola in 2004 to that in 2006?
Provide a succinct answer. 1.01. What is the ratio of the Total Labor Force (in %) of Panama in 2004 to that in 2006?
Offer a terse response. 1.01. What is the ratio of the Total Labor Force (in %) in Angola in 2004 to that in 2007?
Make the answer very short. 1.02. What is the ratio of the Total Labor Force (in %) in Low income in 2005 to that in 2006?
Keep it short and to the point. 1. What is the ratio of the Total Labor Force (in %) in Angola in 2005 to that in 2006?
Give a very brief answer. 1.01. What is the ratio of the Total Labor Force (in %) in Gabon in 2005 to that in 2006?
Your answer should be very brief. 1. What is the ratio of the Total Labor Force (in %) of Panama in 2005 to that in 2006?
Your answer should be compact. 1.01. What is the ratio of the Total Labor Force (in %) of Low income in 2005 to that in 2007?
Provide a succinct answer. 1. What is the ratio of the Total Labor Force (in %) in Angola in 2005 to that in 2007?
Give a very brief answer. 1.01. What is the ratio of the Total Labor Force (in %) in Panama in 2005 to that in 2007?
Your response must be concise. 1. What is the ratio of the Total Labor Force (in %) in Angola in 2006 to that in 2007?
Offer a very short reply. 1.01. What is the ratio of the Total Labor Force (in %) in Panama in 2006 to that in 2007?
Keep it short and to the point. 0.99. What is the difference between the highest and the second highest Total Labor Force (in %) of Low income?
Your answer should be very brief. 0. What is the difference between the highest and the second highest Total Labor Force (in %) in Angola?
Offer a terse response. 0. What is the difference between the highest and the second highest Total Labor Force (in %) of Gabon?
Make the answer very short. 0.2. What is the difference between the highest and the lowest Total Labor Force (in %) of Low income?
Ensure brevity in your answer.  0.67. What is the difference between the highest and the lowest Total Labor Force (in %) in Angola?
Your response must be concise. 2.1. What is the difference between the highest and the lowest Total Labor Force (in %) in Gabon?
Keep it short and to the point. 0.9. What is the difference between the highest and the lowest Total Labor Force (in %) in Panama?
Provide a short and direct response. 1.6. 